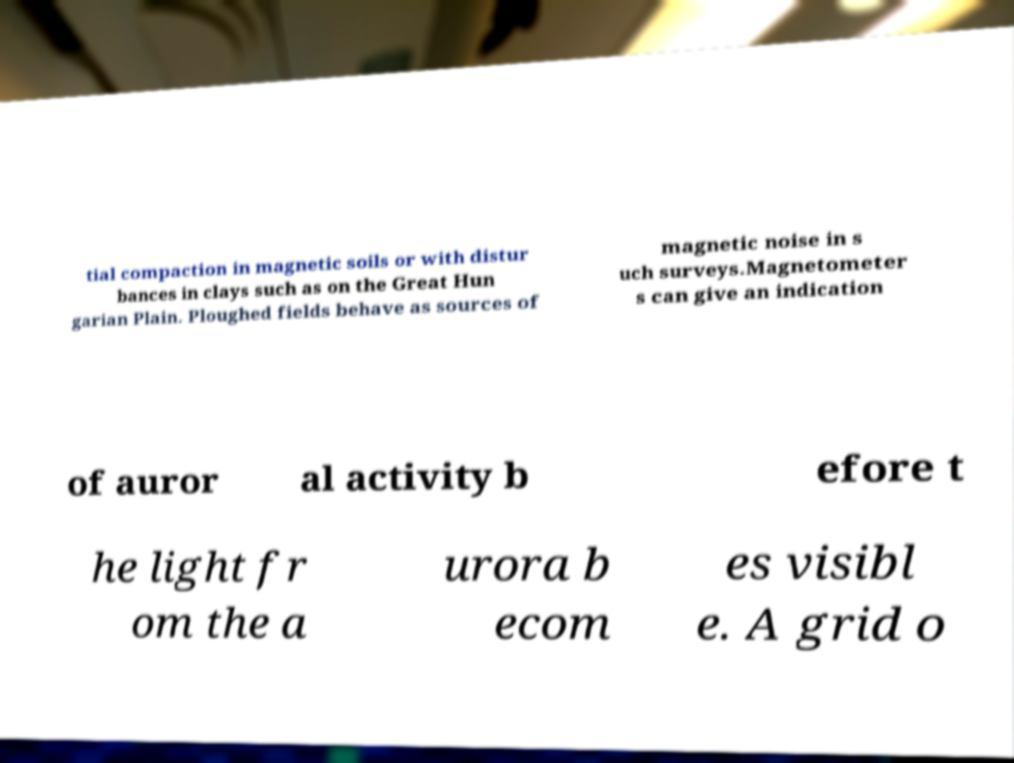Could you assist in decoding the text presented in this image and type it out clearly? tial compaction in magnetic soils or with distur bances in clays such as on the Great Hun garian Plain. Ploughed fields behave as sources of magnetic noise in s uch surveys.Magnetometer s can give an indication of auror al activity b efore t he light fr om the a urora b ecom es visibl e. A grid o 